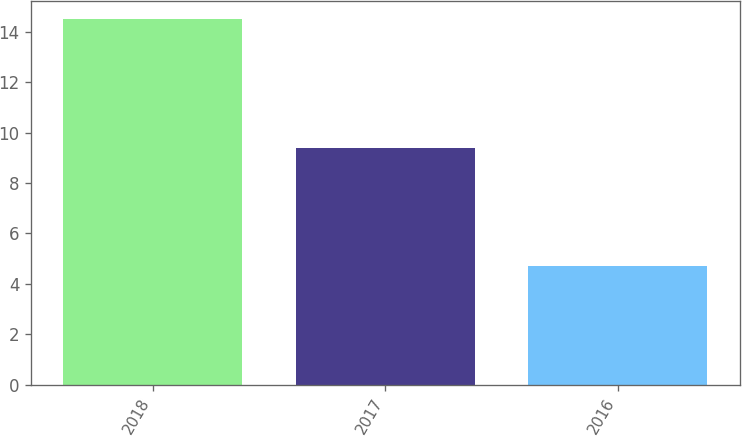Convert chart. <chart><loc_0><loc_0><loc_500><loc_500><bar_chart><fcel>2018<fcel>2017<fcel>2016<nl><fcel>14.5<fcel>9.4<fcel>4.7<nl></chart> 